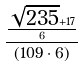Convert formula to latex. <formula><loc_0><loc_0><loc_500><loc_500>\frac { \frac { \sqrt { 2 3 5 } + 1 7 } { 6 } } { ( 1 0 9 \cdot 6 ) }</formula> 